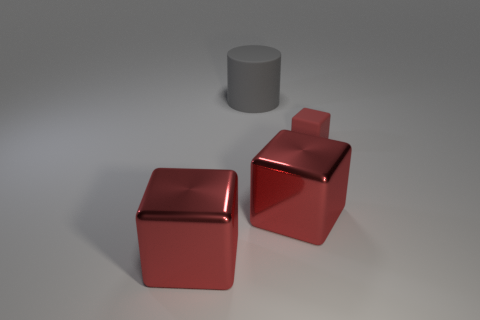Is there a red object of the same shape as the big gray matte object?
Your answer should be very brief. No. There is a gray matte cylinder; is its size the same as the shiny cube on the right side of the large gray rubber thing?
Your answer should be compact. Yes. How many objects are either red blocks in front of the rubber block or matte things on the left side of the tiny red matte object?
Offer a terse response. 3. Is the number of large red metal things that are on the right side of the large gray rubber cylinder greater than the number of big brown balls?
Provide a succinct answer. Yes. How many other objects are the same size as the gray rubber thing?
Make the answer very short. 2. There is a matte thing behind the small red cube; is its size the same as the red shiny object left of the gray cylinder?
Give a very brief answer. Yes. How big is the rubber thing that is behind the small cube?
Your answer should be compact. Large. There is a block that is left of the big red object right of the large cylinder; what is its size?
Provide a succinct answer. Large. There is a big matte cylinder; are there any small cubes on the right side of it?
Offer a very short reply. Yes. Is the number of big cylinders that are behind the large gray cylinder the same as the number of gray matte objects?
Your answer should be very brief. No. 